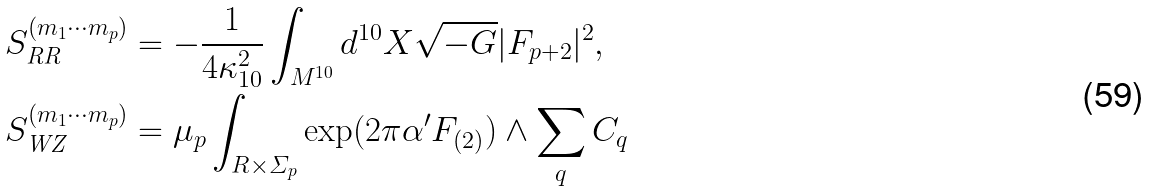<formula> <loc_0><loc_0><loc_500><loc_500>S _ { \text {RR} } ^ { ( m _ { 1 } \cdots m _ { p } ) } & = - \frac { 1 } { 4 \kappa _ { 1 0 } ^ { 2 } } \int _ { M ^ { 1 0 } } d ^ { 1 0 } X \sqrt { - G } | F _ { p + 2 } | ^ { 2 } , \\ S _ { \text {WZ} } ^ { ( m _ { 1 } \cdots m _ { p } ) } & = \mu _ { p } \int _ { R \times \varSigma _ { p } } \exp ( 2 \pi \alpha ^ { \prime } F _ { ( 2 ) } ) \wedge \sum _ { q } C _ { q }</formula> 